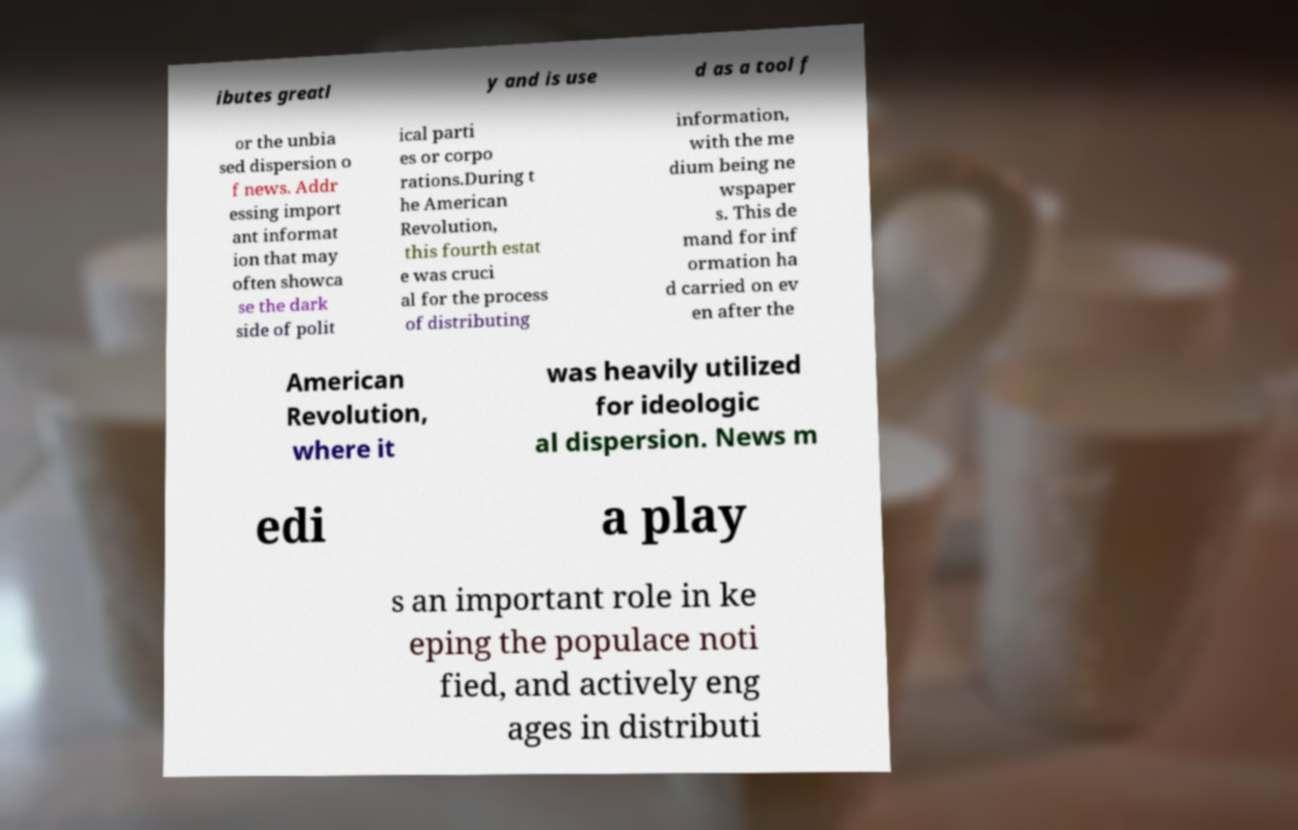I need the written content from this picture converted into text. Can you do that? ibutes greatl y and is use d as a tool f or the unbia sed dispersion o f news. Addr essing import ant informat ion that may often showca se the dark side of polit ical parti es or corpo rations.During t he American Revolution, this fourth estat e was cruci al for the process of distributing information, with the me dium being ne wspaper s. This de mand for inf ormation ha d carried on ev en after the American Revolution, where it was heavily utilized for ideologic al dispersion. News m edi a play s an important role in ke eping the populace noti fied, and actively eng ages in distributi 